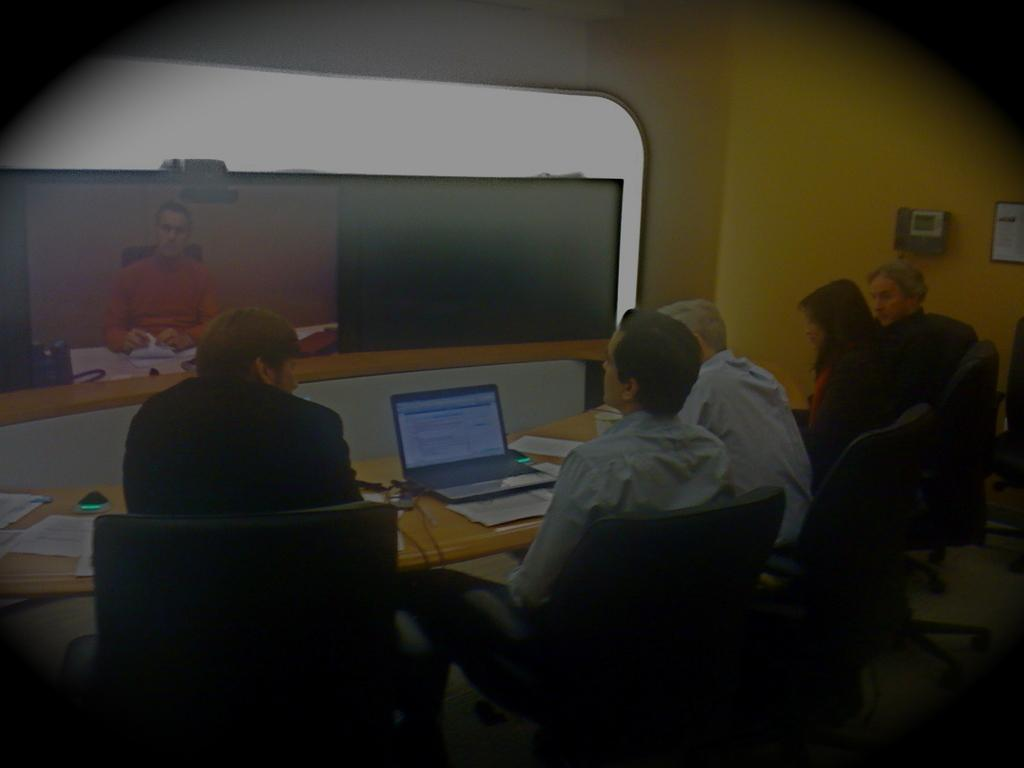What are the people in the image doing? The people in the image are sitting on chairs. What is in front of the chairs? There is a table in front of the chairs. What items can be seen on the table? Papers and a laptop are present on the table. What can be seen on the screen in the image? There is a screen in the image, but the content is not specified. What type of structure is visible in the image? There are walls visible in the image, suggesting an indoor setting. What type of downtown area is visible in the image? There is no downtown area visible in the image; it features people sitting on chairs with a table and other items. 